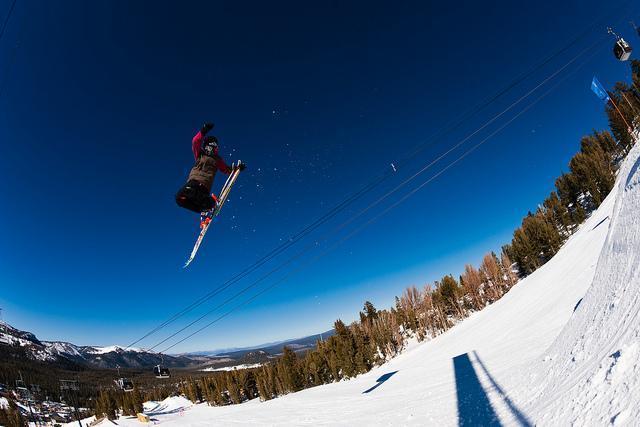How many people are visible?
Give a very brief answer. 1. How many pink donuts are there?
Give a very brief answer. 0. 